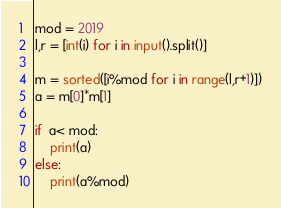<code> <loc_0><loc_0><loc_500><loc_500><_Python_>mod = 2019
l,r = [int(i) for i in input().split()]

m = sorted([i%mod for i in range(l,r+1)])
a = m[0]*m[1]

if  a< mod:
    print(a)
else:
    print(a%mod)</code> 